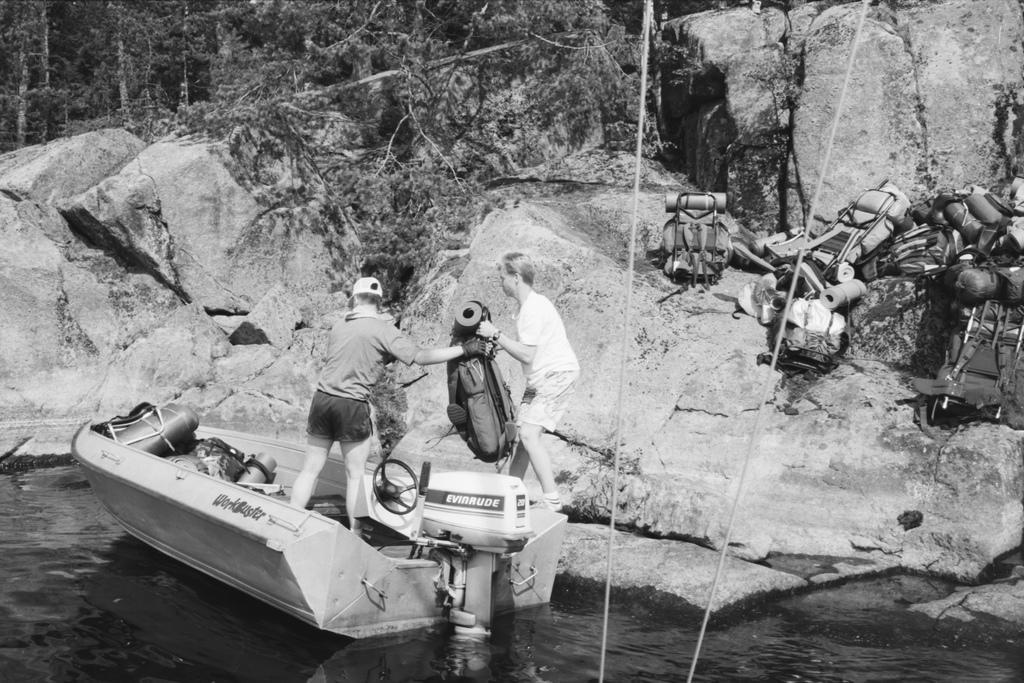Describe this image in one or two sentences. In this image there is a person standing on the boat, which is on the river and there is another person standing on the rock and both are holding a bag. On the right side of the image there are so many objects on the rocks. In the background there are trees. 